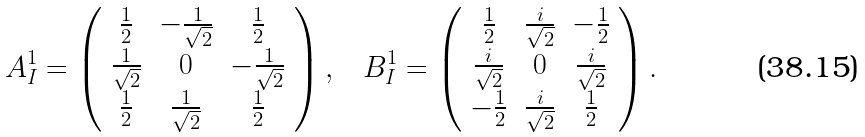Convert formula to latex. <formula><loc_0><loc_0><loc_500><loc_500>A _ { I } ^ { 1 } = \left ( \begin{array} { c c c } \frac { 1 } { 2 } & - \frac { 1 } { \sqrt { 2 } } & \frac { 1 } { 2 } \\ \frac { 1 } { \sqrt { 2 } } & 0 & - \frac { 1 } { \sqrt { 2 } } \\ \frac { 1 } { 2 } & \frac { 1 } { \sqrt { 2 } } & \frac { 1 } { 2 } \end{array} \right ) , \quad & B _ { I } ^ { 1 } = \left ( \begin{array} { c c c } \frac { 1 } { 2 } & \frac { i } { \sqrt { 2 } } & - \frac { 1 } { 2 } \\ \frac { i } { \sqrt { 2 } } & 0 & \frac { i } { \sqrt { 2 } } \\ - \frac { 1 } { 2 } & \frac { i } { \sqrt { 2 } } & \frac { 1 } { 2 } \end{array} \right ) .</formula> 